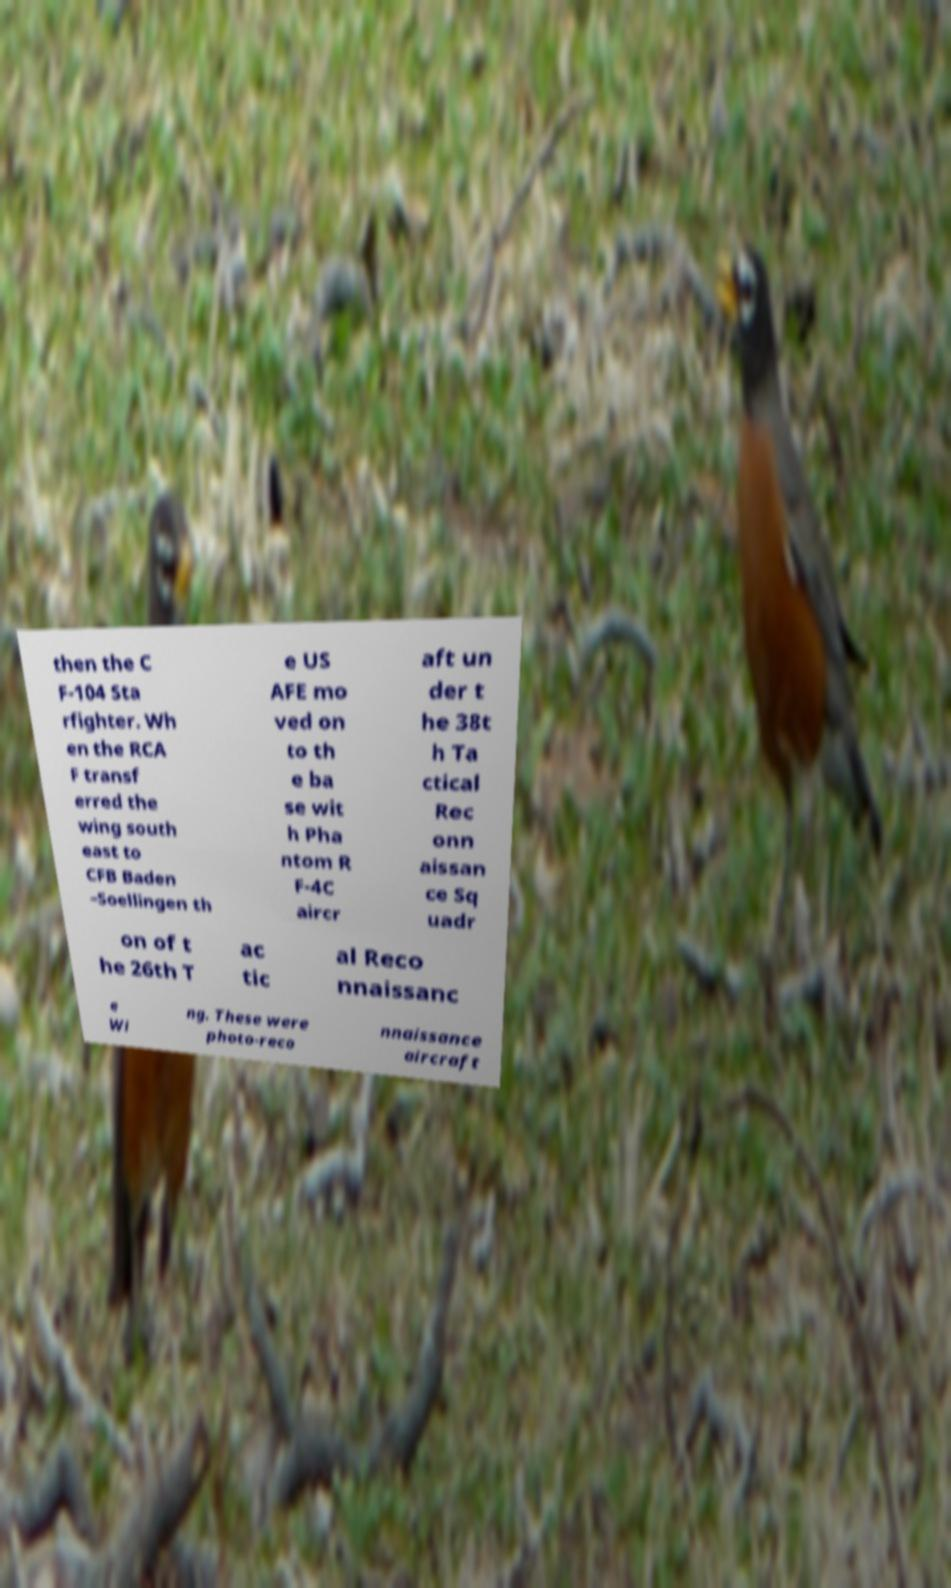Can you accurately transcribe the text from the provided image for me? then the C F-104 Sta rfighter. Wh en the RCA F transf erred the wing south east to CFB Baden –Soellingen th e US AFE mo ved on to th e ba se wit h Pha ntom R F-4C aircr aft un der t he 38t h Ta ctical Rec onn aissan ce Sq uadr on of t he 26th T ac tic al Reco nnaissanc e Wi ng. These were photo-reco nnaissance aircraft 